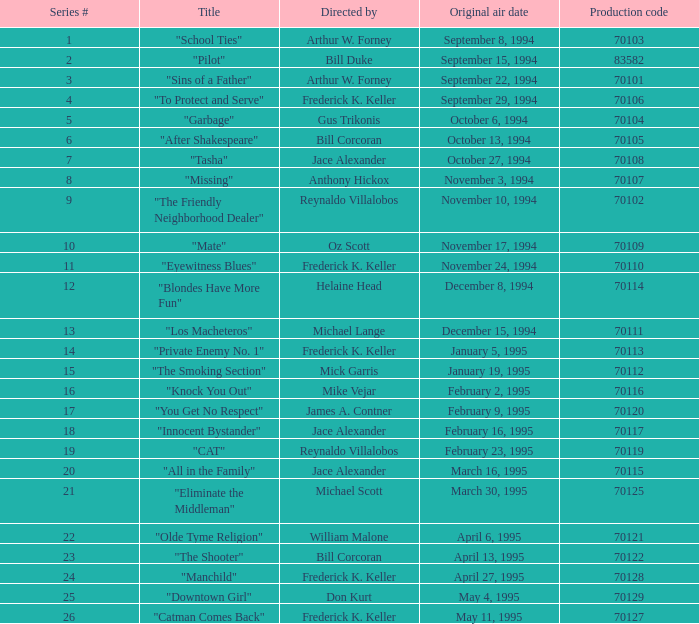For the "Downtown Girl" episode, what was the original air date? May 4, 1995. 